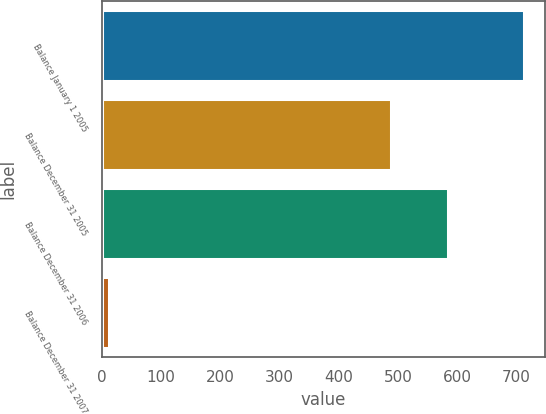Convert chart to OTSL. <chart><loc_0><loc_0><loc_500><loc_500><bar_chart><fcel>Balance January 1 2005<fcel>Balance December 31 2005<fcel>Balance December 31 2006<fcel>Balance December 31 2007<nl><fcel>713<fcel>489<fcel>584<fcel>12<nl></chart> 